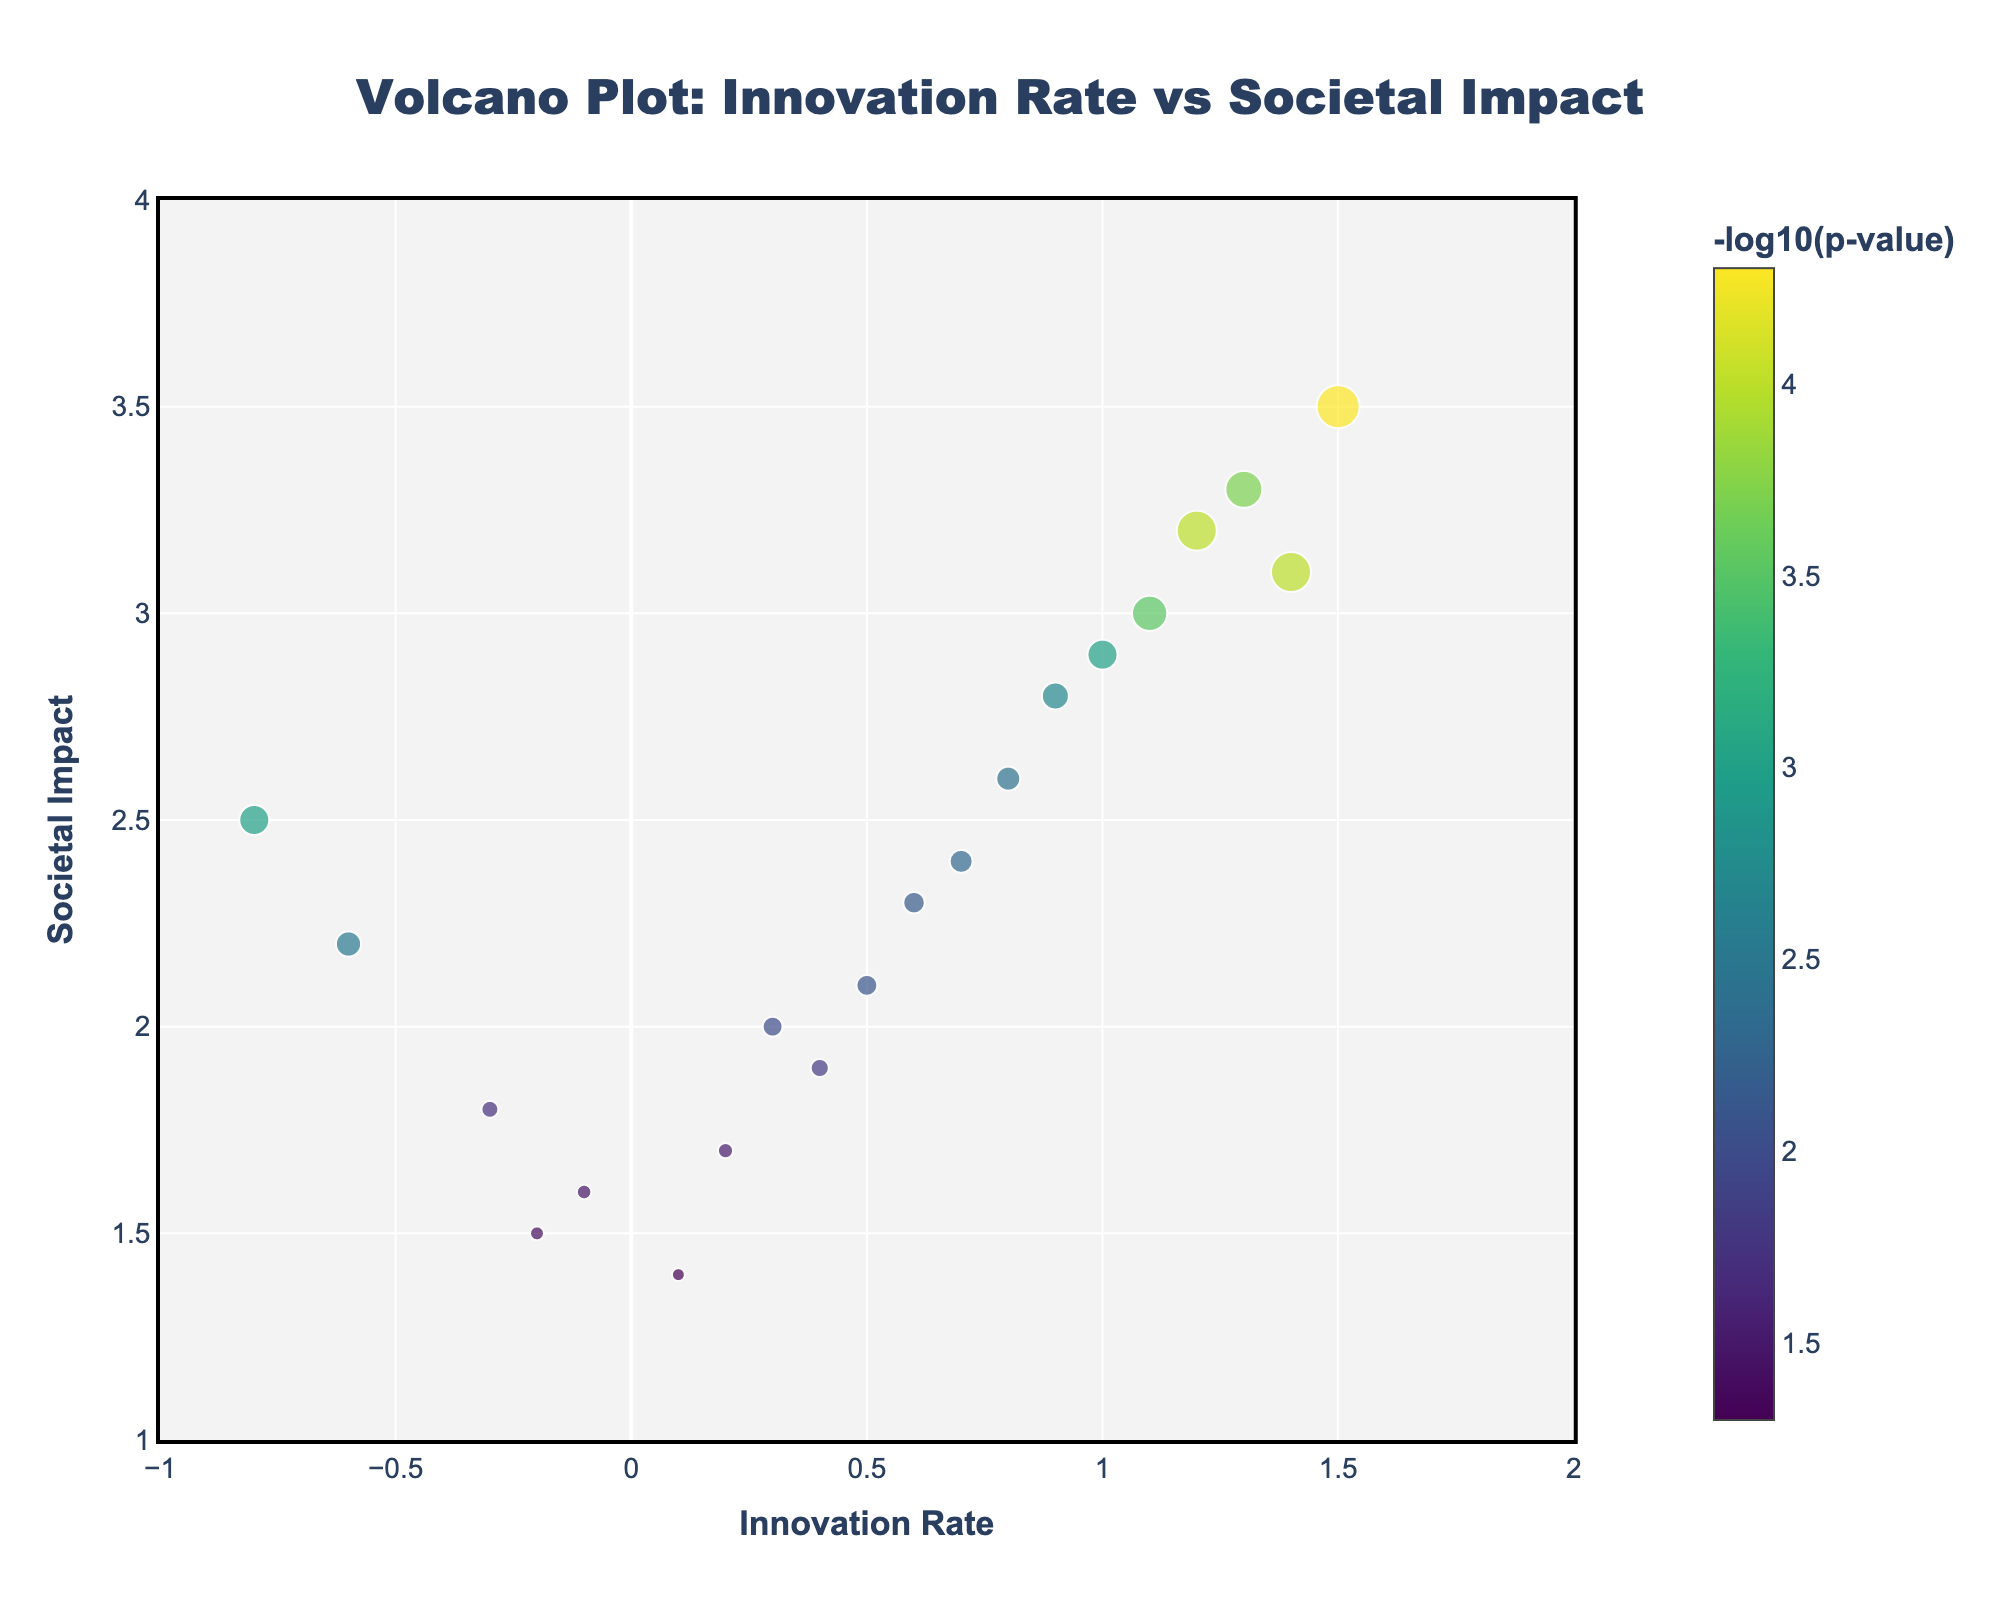What does the title of the figure say? The title of the figure is usually located at the top and provides an overview of what the plot represents. Here, the title states: "Volcano Plot: Innovation Rate vs Societal Impact"
Answer: Volcano Plot: Innovation Rate vs Societal Impact What do the sizes and colors of the markers represent? In the figure, the sizes of the markers represent the -log10(p-value). Larger sizes indicate smaller p-values (higher significance). The colors also represent the -log10(p-value), with a color scale where typically darker colors indicate more significant values. This is confirmed by the color legend titled "-log10(p-value)".
Answer: Sizes and colors of markers represent -log10(p-value) Which technological advancement has the highest societal impact? By observing the y-axis (Societal Impact) and locating the highest point on the plot, we find the data point corresponding to the "Sumerian wheel" at a societal impact value of 3.5, which is the maximum on the y-axis.
Answer: Sumerian wheel How many technological advancements have a negative innovation rate? Look for the markers that are located to the left of the y-axis (x = 0). Counting these markers: "Mesopotamian cuneiform," "Egyptian hieroglyphs," "Indus Valley seals," "Minoan Linear A," "Mycenaean Linear B," and "Zapotec writing system." Thus, there are six.
Answer: Six Which two technological advancements have an innovation rate close to 0 but different societal impacts? Look near x = 0, and compare their y-values (Societal Impact). "Mycenaean Linear B" (1.6) and "Zapotec writing system" (1.7) both have innovation rates close to 0.
Answer: Mycenaean Linear B and Zapotec Writing System What is the innovation rate and societal impact difference between Greek pottery techniques and Chinese silk production? Find the coordinates of both data points: Greek pottery techniques (0.8, 2.6) and Chinese silk production (1.0, 2.9). Calculate the differences: Innovation rate difference = 1.0 - 0.8 = 0.2, Societal Impact difference = 2.9 - 2.6 = 0.3.
Answer: Innovation rate: 0.2, Societal impact: 0.3 Which technological advancement has the least significant p-value? The least significant p-value will have the smallest -log10(p-value), seen as the smallest markers. The smallest marker is "Nok terracotta sculptures" which has a p-value of 0.05, translating to the smallest -log10(p-value).
Answer: Nok terracotta sculptures Name a technological advancement with both a high innovation rate and societal impact? Look for a data point that is located towards the top right of the plot. "Sumerian wheel" (1.5, 3.5) and "Egyptian pyramid construction" (1.3, 3.3) both have a high innovation rate and high societal impact.
Answer: Sumerian wheel or Egyptian pyramid construction 